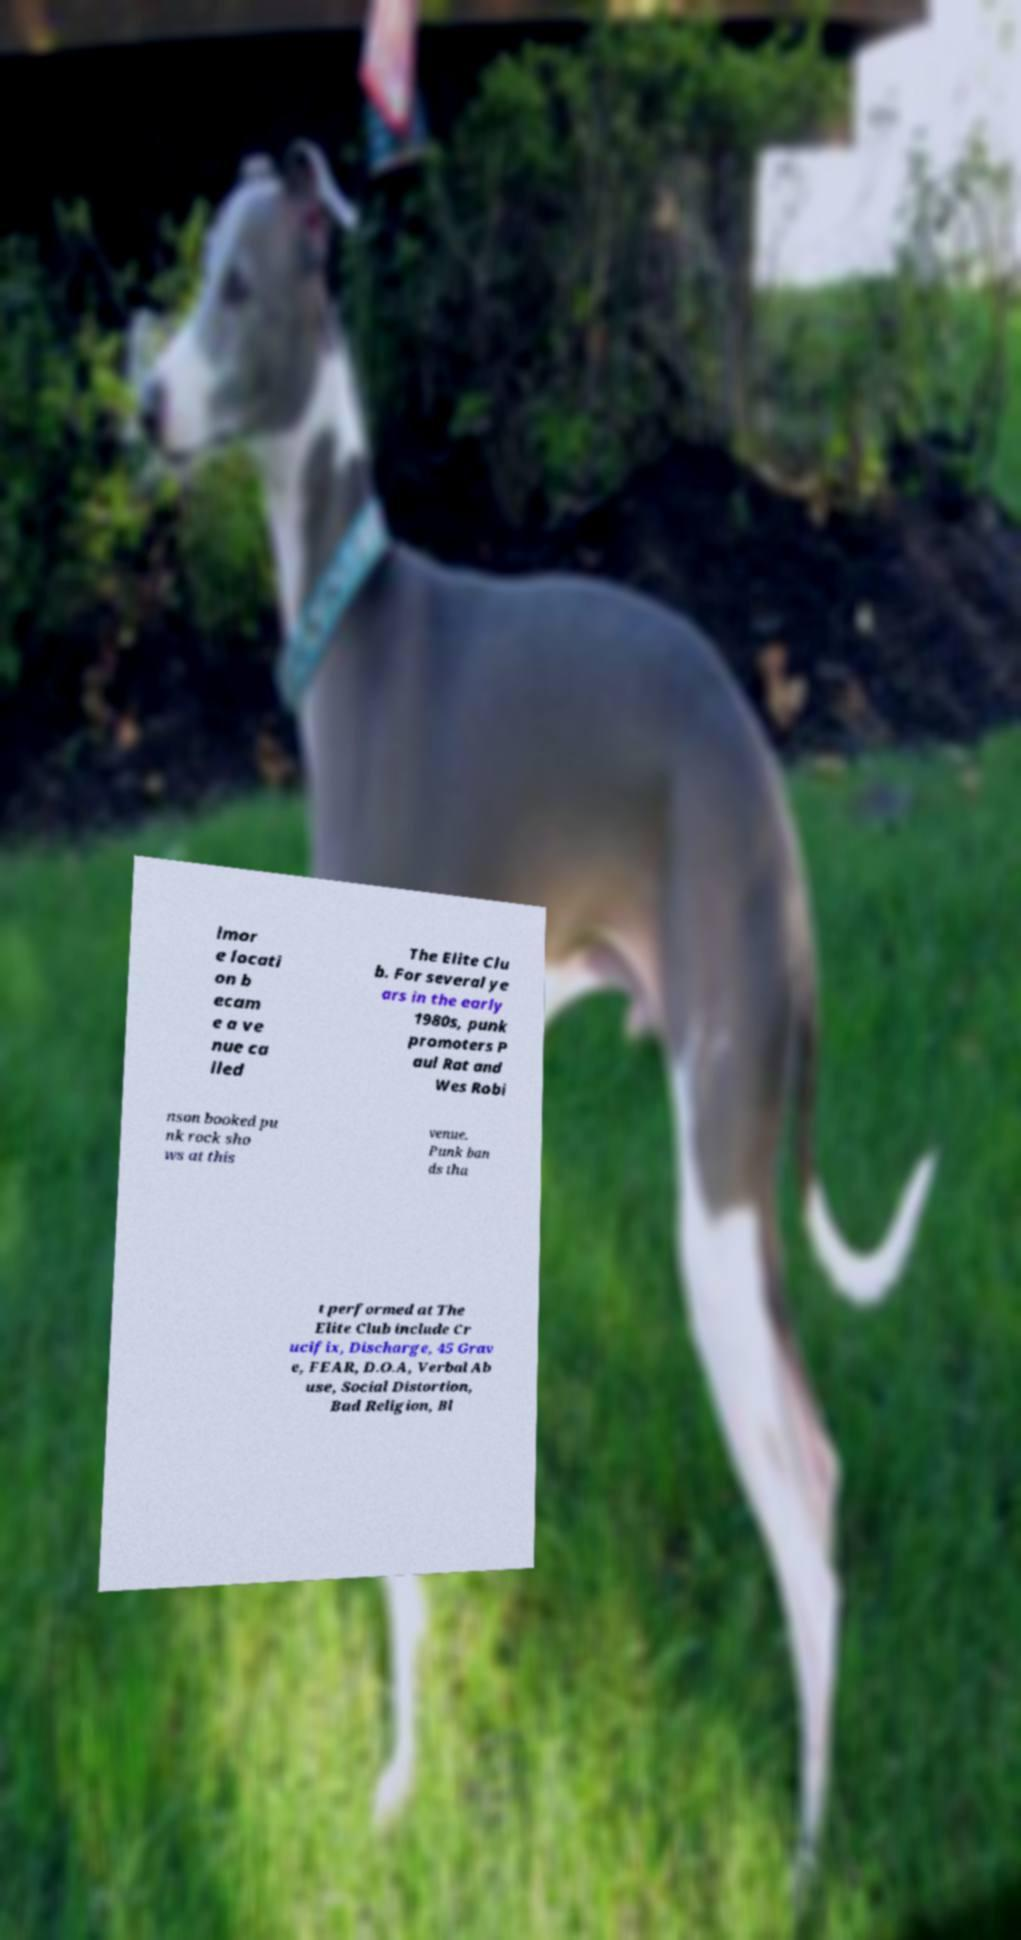There's text embedded in this image that I need extracted. Can you transcribe it verbatim? lmor e locati on b ecam e a ve nue ca lled The Elite Clu b. For several ye ars in the early 1980s, punk promoters P aul Rat and Wes Robi nson booked pu nk rock sho ws at this venue. Punk ban ds tha t performed at The Elite Club include Cr ucifix, Discharge, 45 Grav e, FEAR, D.O.A, Verbal Ab use, Social Distortion, Bad Religion, Bl 